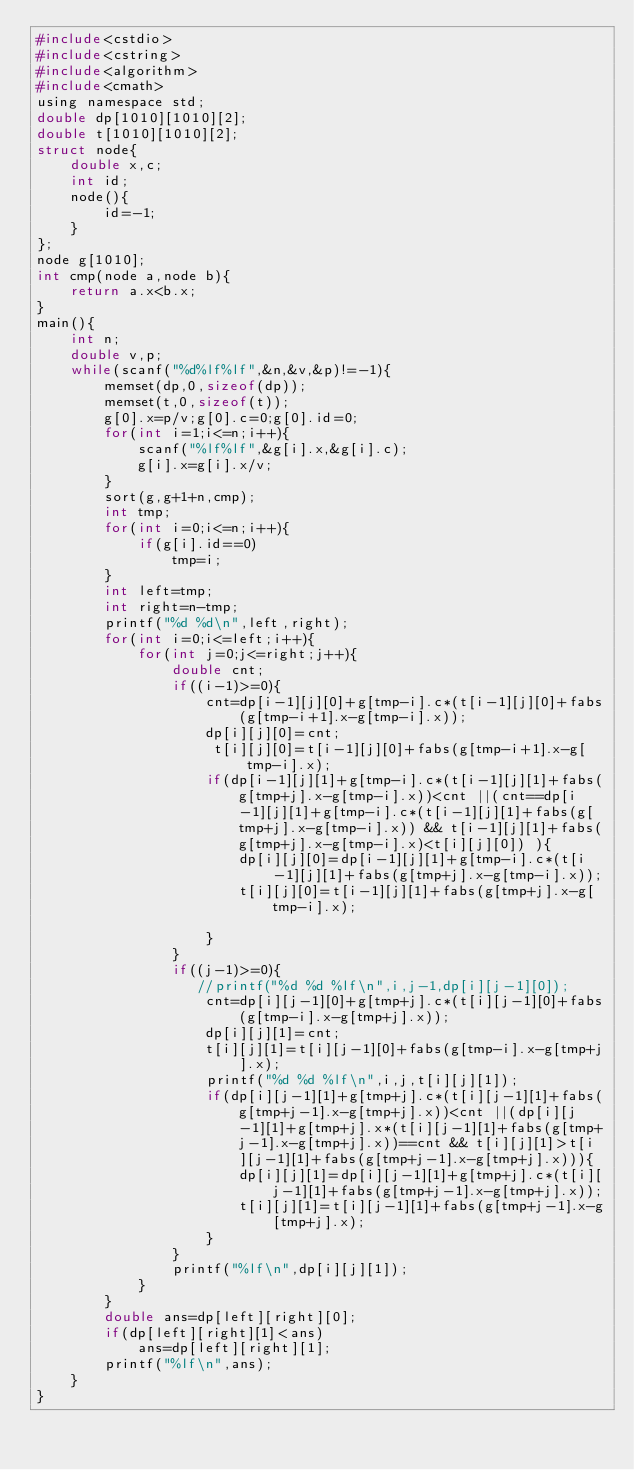<code> <loc_0><loc_0><loc_500><loc_500><_C_>#include<cstdio>
#include<cstring>
#include<algorithm>
#include<cmath>
using namespace std;
double dp[1010][1010][2];
double t[1010][1010][2];
struct node{
    double x,c;
    int id;
    node(){
        id=-1;
    }
};
node g[1010];
int cmp(node a,node b){
    return a.x<b.x;
}
main(){
    int n;
    double v,p;
    while(scanf("%d%lf%lf",&n,&v,&p)!=-1){
        memset(dp,0,sizeof(dp));
        memset(t,0,sizeof(t));
        g[0].x=p/v;g[0].c=0;g[0].id=0;
        for(int i=1;i<=n;i++){
            scanf("%lf%lf",&g[i].x,&g[i].c);
            g[i].x=g[i].x/v;
        }
        sort(g,g+1+n,cmp);
        int tmp;
        for(int i=0;i<=n;i++){
            if(g[i].id==0)
                tmp=i;
        }
        int left=tmp;
        int right=n-tmp;
        printf("%d %d\n",left,right);
        for(int i=0;i<=left;i++){
            for(int j=0;j<=right;j++){
                double cnt;
                if((i-1)>=0){
                    cnt=dp[i-1][j][0]+g[tmp-i].c*(t[i-1][j][0]+fabs(g[tmp-i+1].x-g[tmp-i].x));
                    dp[i][j][0]=cnt;
                     t[i][j][0]=t[i-1][j][0]+fabs(g[tmp-i+1].x-g[tmp-i].x);
                    if(dp[i-1][j][1]+g[tmp-i].c*(t[i-1][j][1]+fabs(g[tmp+j].x-g[tmp-i].x))<cnt ||(cnt==dp[i-1][j][1]+g[tmp-i].c*(t[i-1][j][1]+fabs(g[tmp+j].x-g[tmp-i].x)) && t[i-1][j][1]+fabs(g[tmp+j].x-g[tmp-i].x)<t[i][j][0]) ){
                        dp[i][j][0]=dp[i-1][j][1]+g[tmp-i].c*(t[i-1][j][1]+fabs(g[tmp+j].x-g[tmp-i].x));
                        t[i][j][0]=t[i-1][j][1]+fabs(g[tmp+j].x-g[tmp-i].x);

                    }
                }
                if((j-1)>=0){
                   //printf("%d %d %lf\n",i,j-1,dp[i][j-1][0]);
                    cnt=dp[i][j-1][0]+g[tmp+j].c*(t[i][j-1][0]+fabs(g[tmp-i].x-g[tmp+j].x));
                    dp[i][j][1]=cnt;
                    t[i][j][1]=t[i][j-1][0]+fabs(g[tmp-i].x-g[tmp+j].x);
                    printf("%d %d %lf\n",i,j,t[i][j][1]);
                    if(dp[i][j-1][1]+g[tmp+j].c*(t[i][j-1][1]+fabs(g[tmp+j-1].x-g[tmp+j].x))<cnt ||(dp[i][j-1][1]+g[tmp+j].x*(t[i][j-1][1]+fabs(g[tmp+j-1].x-g[tmp+j].x))==cnt && t[i][j][1]>t[i][j-1][1]+fabs(g[tmp+j-1].x-g[tmp+j].x))){
                        dp[i][j][1]=dp[i][j-1][1]+g[tmp+j].c*(t[i][j-1][1]+fabs(g[tmp+j-1].x-g[tmp+j].x));
                        t[i][j][1]=t[i][j-1][1]+fabs(g[tmp+j-1].x-g[tmp+j].x);
                    }
                }
                printf("%lf\n",dp[i][j][1]);
            }
        }
        double ans=dp[left][right][0];
        if(dp[left][right][1]<ans)
            ans=dp[left][right][1];
        printf("%lf\n",ans);
    }
}</code> 